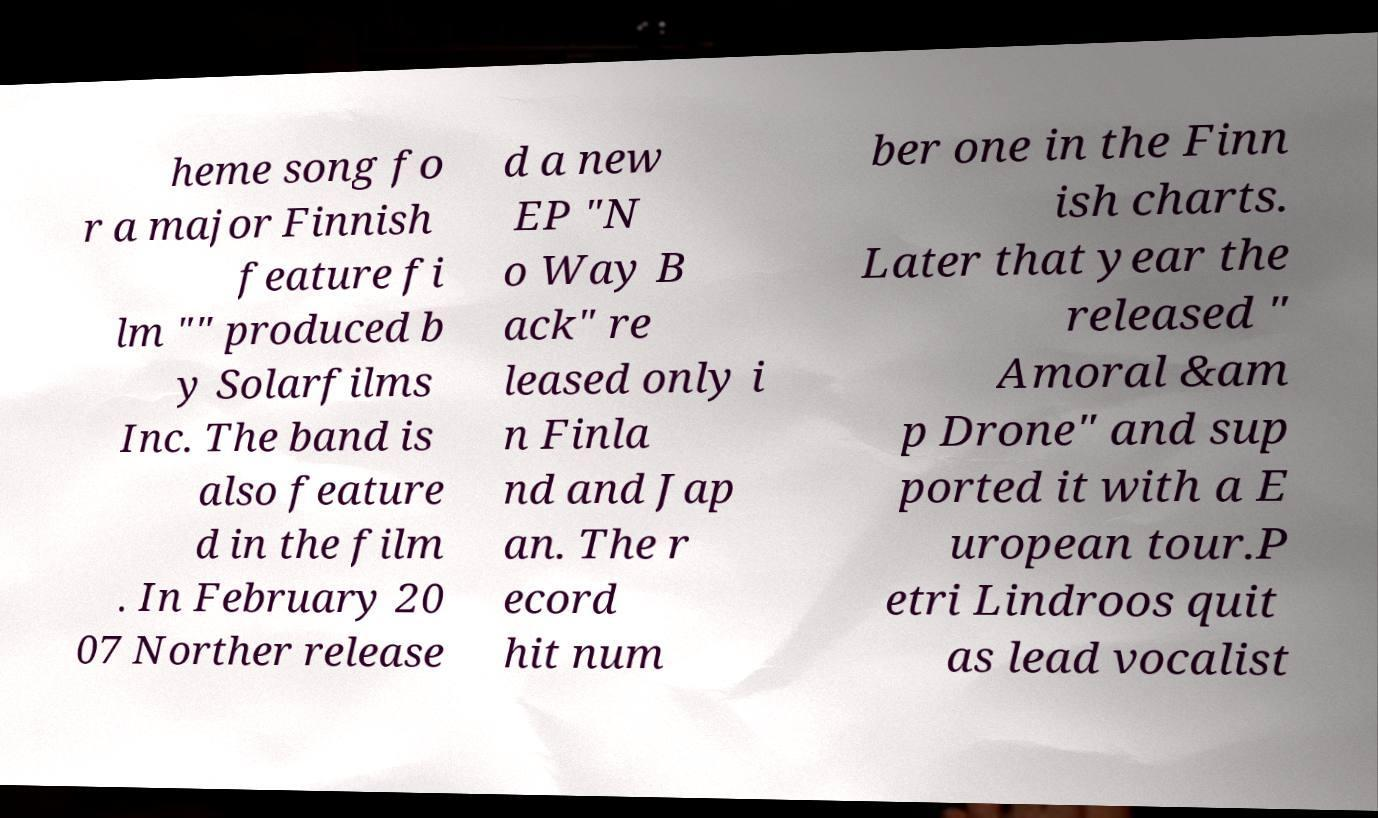What messages or text are displayed in this image? I need them in a readable, typed format. heme song fo r a major Finnish feature fi lm "" produced b y Solarfilms Inc. The band is also feature d in the film . In February 20 07 Norther release d a new EP "N o Way B ack" re leased only i n Finla nd and Jap an. The r ecord hit num ber one in the Finn ish charts. Later that year the released " Amoral &am p Drone" and sup ported it with a E uropean tour.P etri Lindroos quit as lead vocalist 